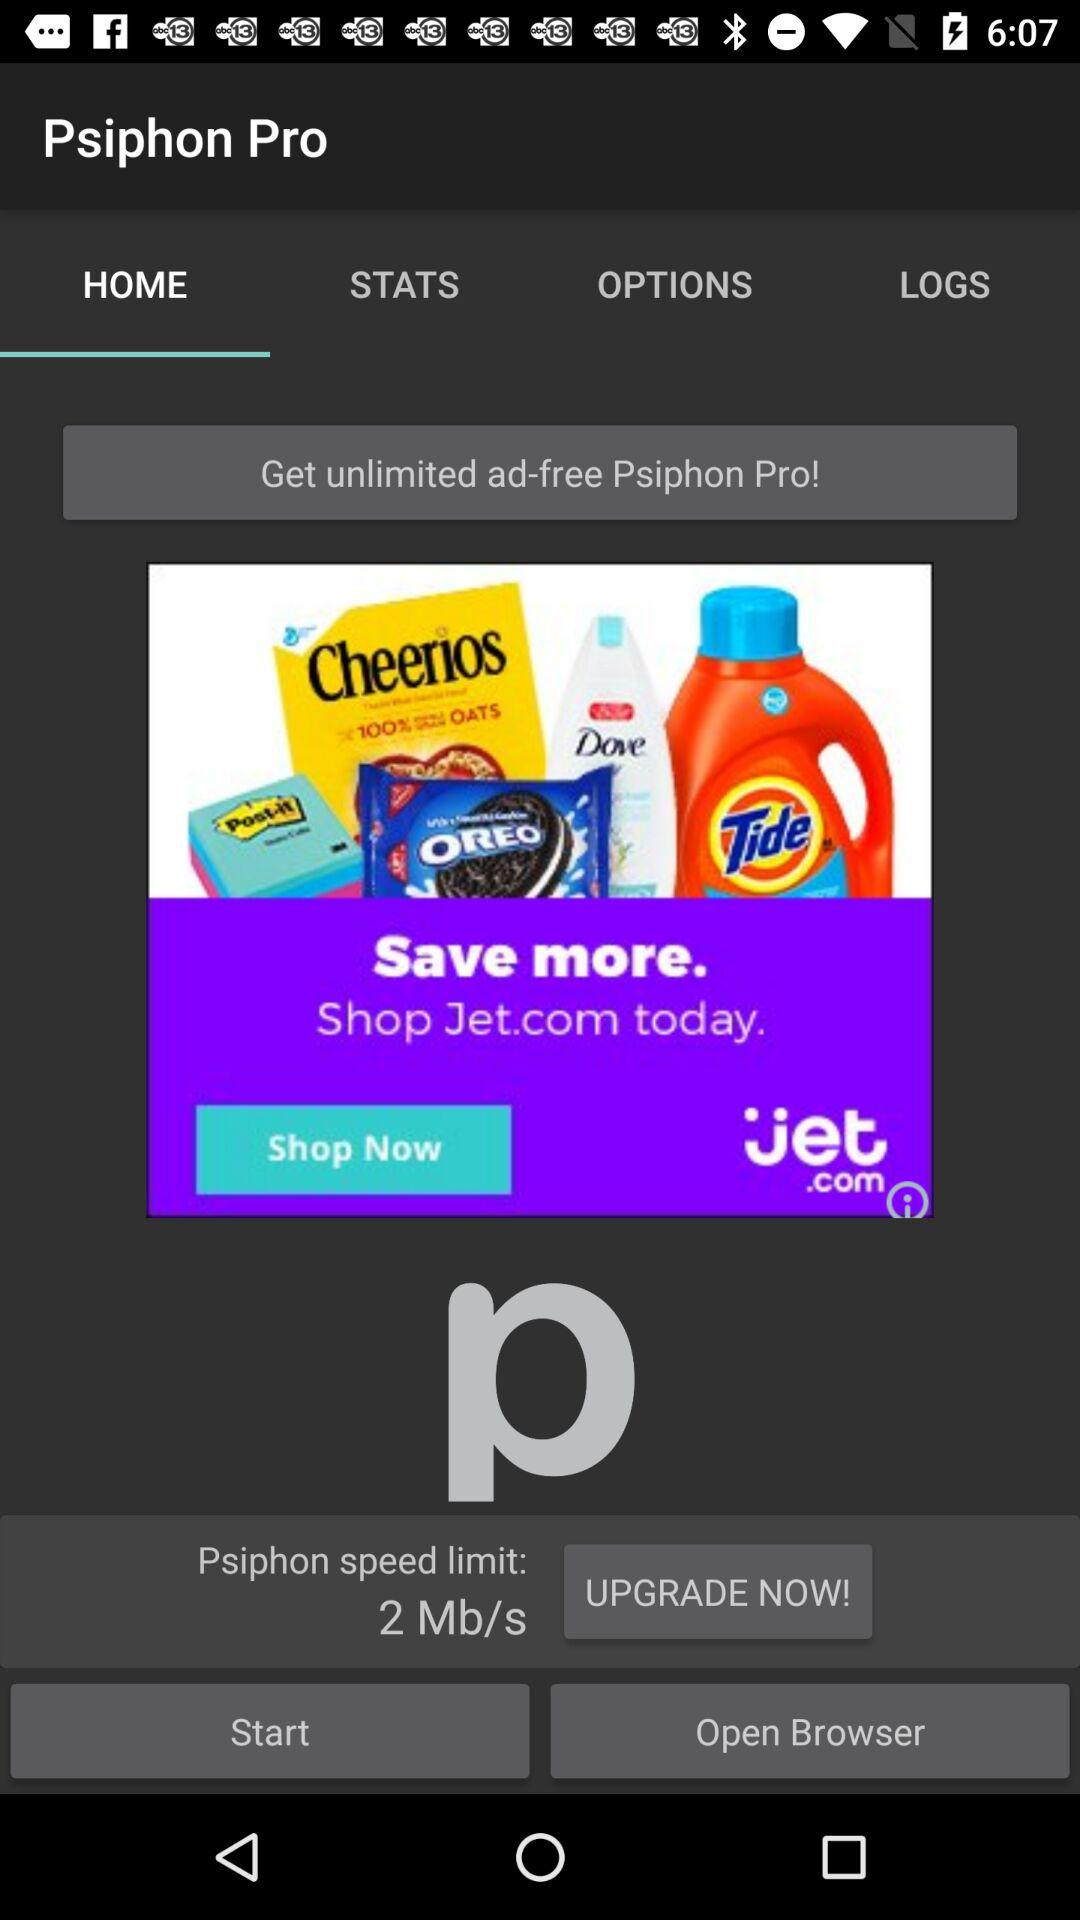What is the "Psiphon" speed limit? The "Psiphon" speed limit is 2 Mb/s. 